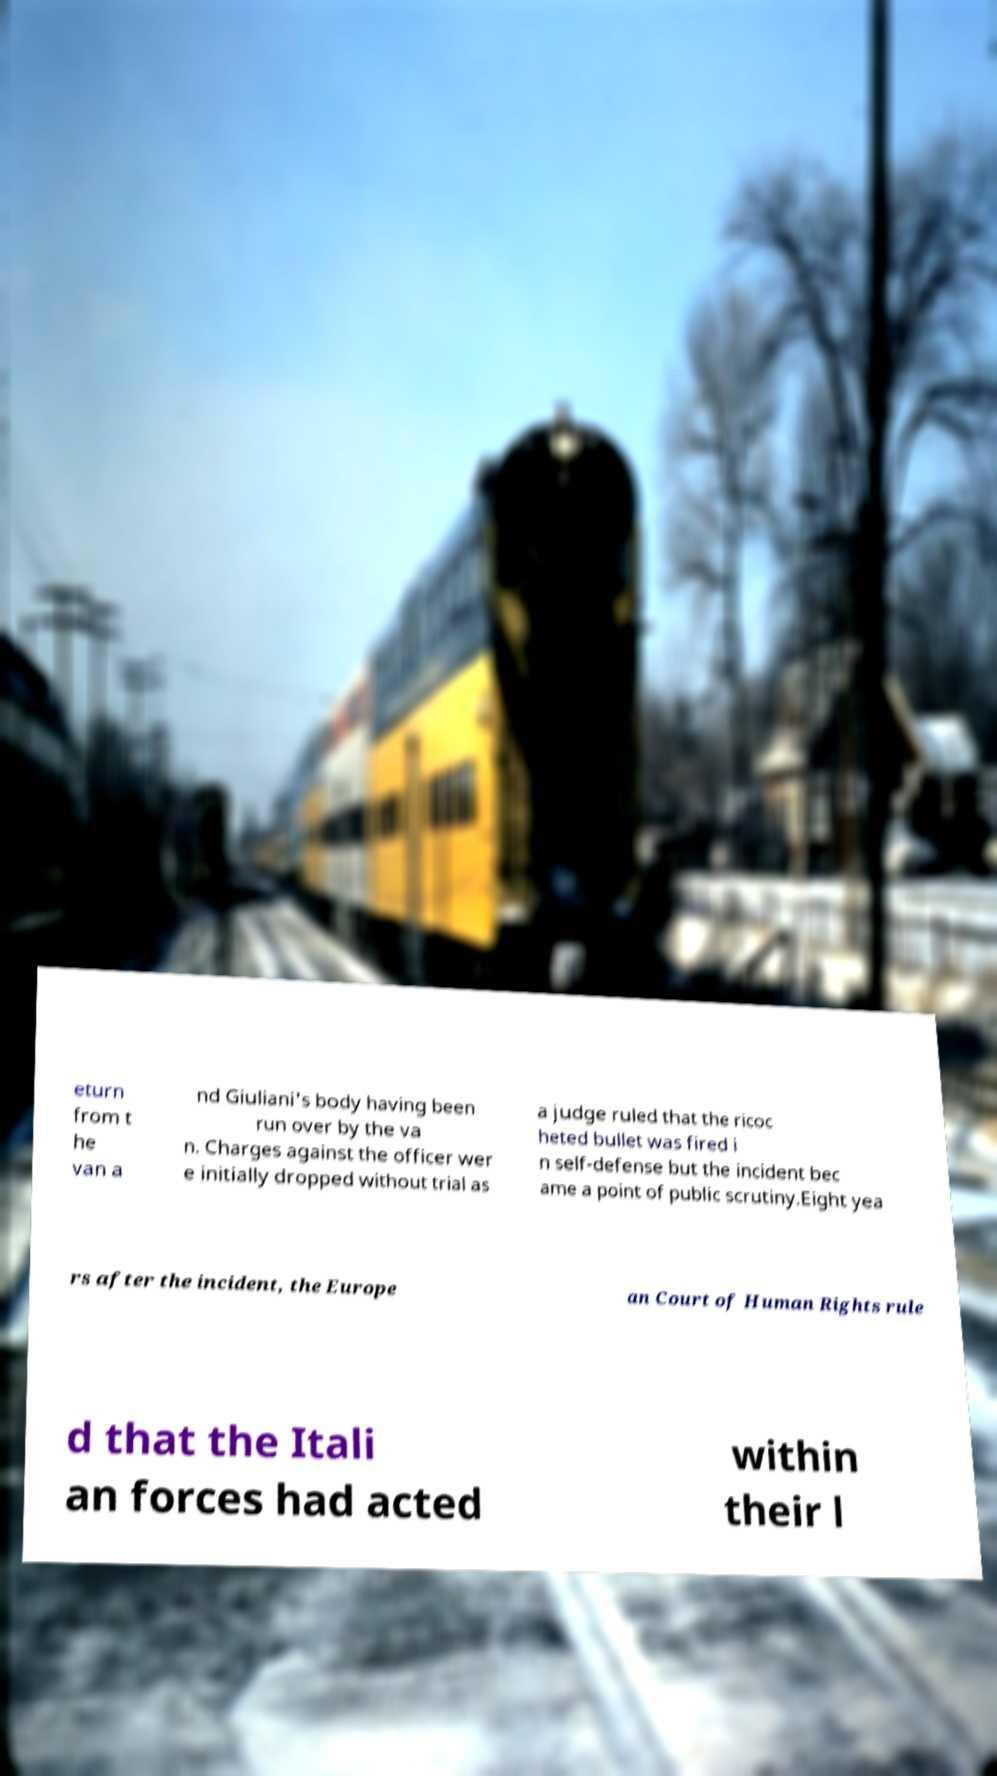Can you read and provide the text displayed in the image?This photo seems to have some interesting text. Can you extract and type it out for me? eturn from t he van a nd Giuliani's body having been run over by the va n. Charges against the officer wer e initially dropped without trial as a judge ruled that the ricoc heted bullet was fired i n self-defense but the incident bec ame a point of public scrutiny.Eight yea rs after the incident, the Europe an Court of Human Rights rule d that the Itali an forces had acted within their l 